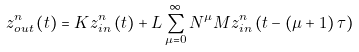Convert formula to latex. <formula><loc_0><loc_0><loc_500><loc_500>z _ { o u t } ^ { n } \left ( t \right ) = K z _ { i n } ^ { n } \left ( t \right ) + L \sum _ { \mu = 0 } ^ { \infty } N ^ { \mu } M z _ { i n } ^ { n } \left ( t - \left ( \mu + 1 \right ) \tau \right )</formula> 